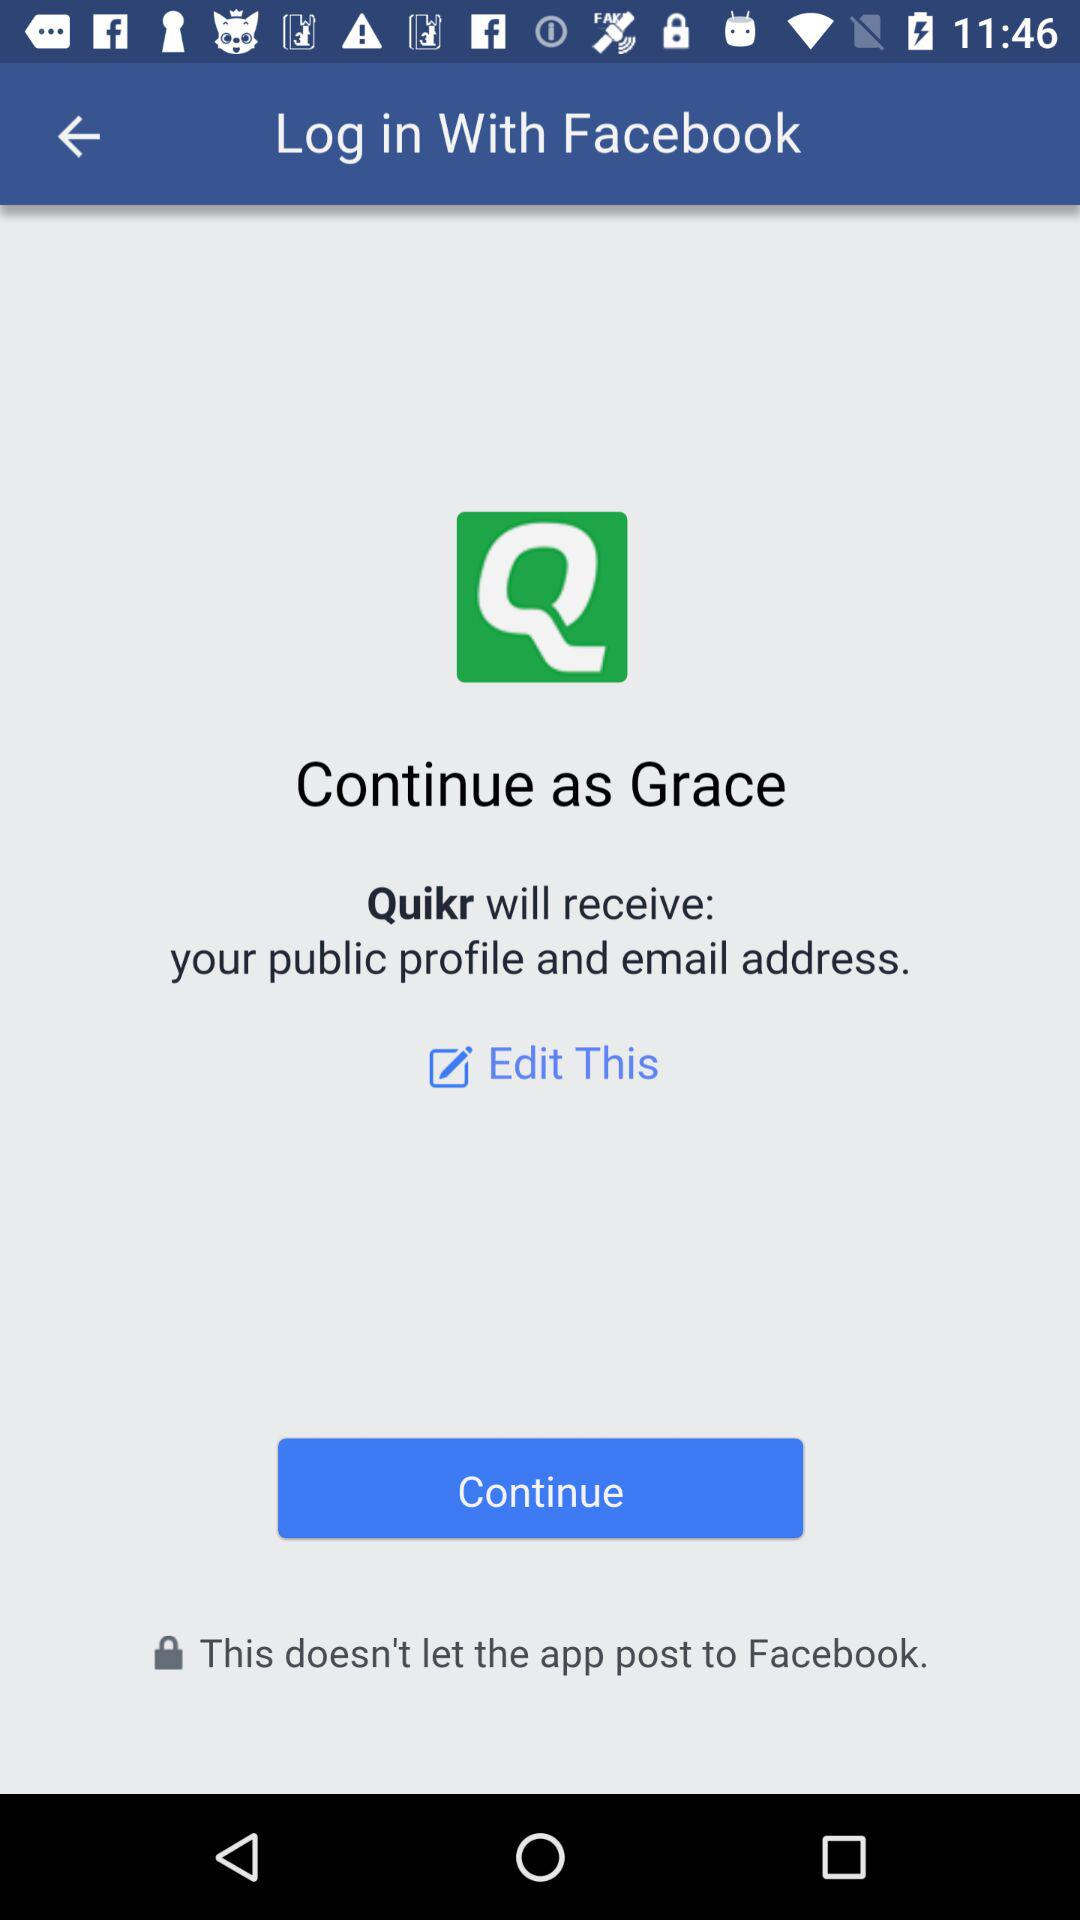What's the user name by which the application can be continued? The user name is Grace. 